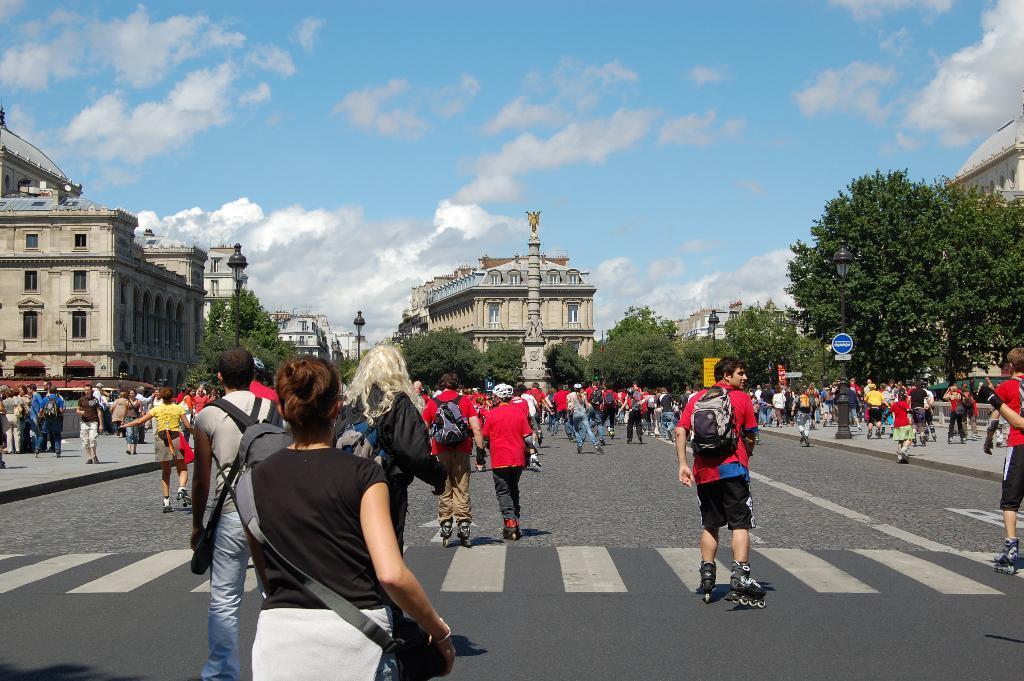Could you give a brief overview of what you see in this image? The image is taken in the streets. In the foreground of the picture we can see many people skating on the road. In the center of the picture there are trees, building. In the background it is sky, sky is partially cloudy. 